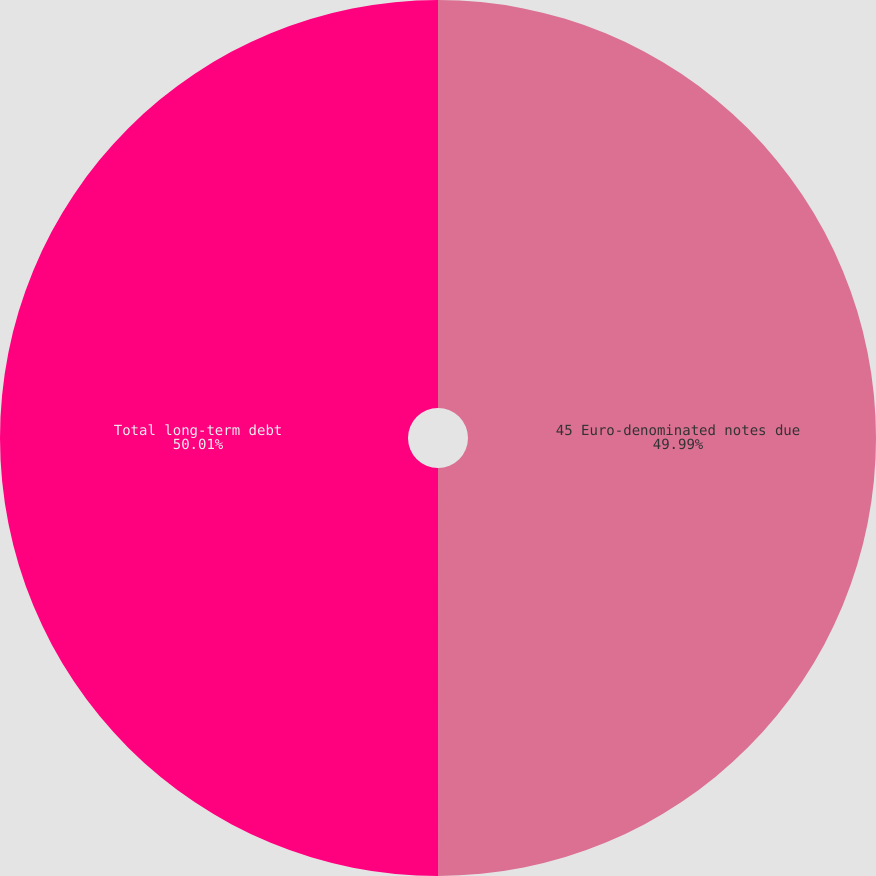Convert chart to OTSL. <chart><loc_0><loc_0><loc_500><loc_500><pie_chart><fcel>45 Euro-denominated notes due<fcel>Total long-term debt<nl><fcel>49.99%<fcel>50.01%<nl></chart> 